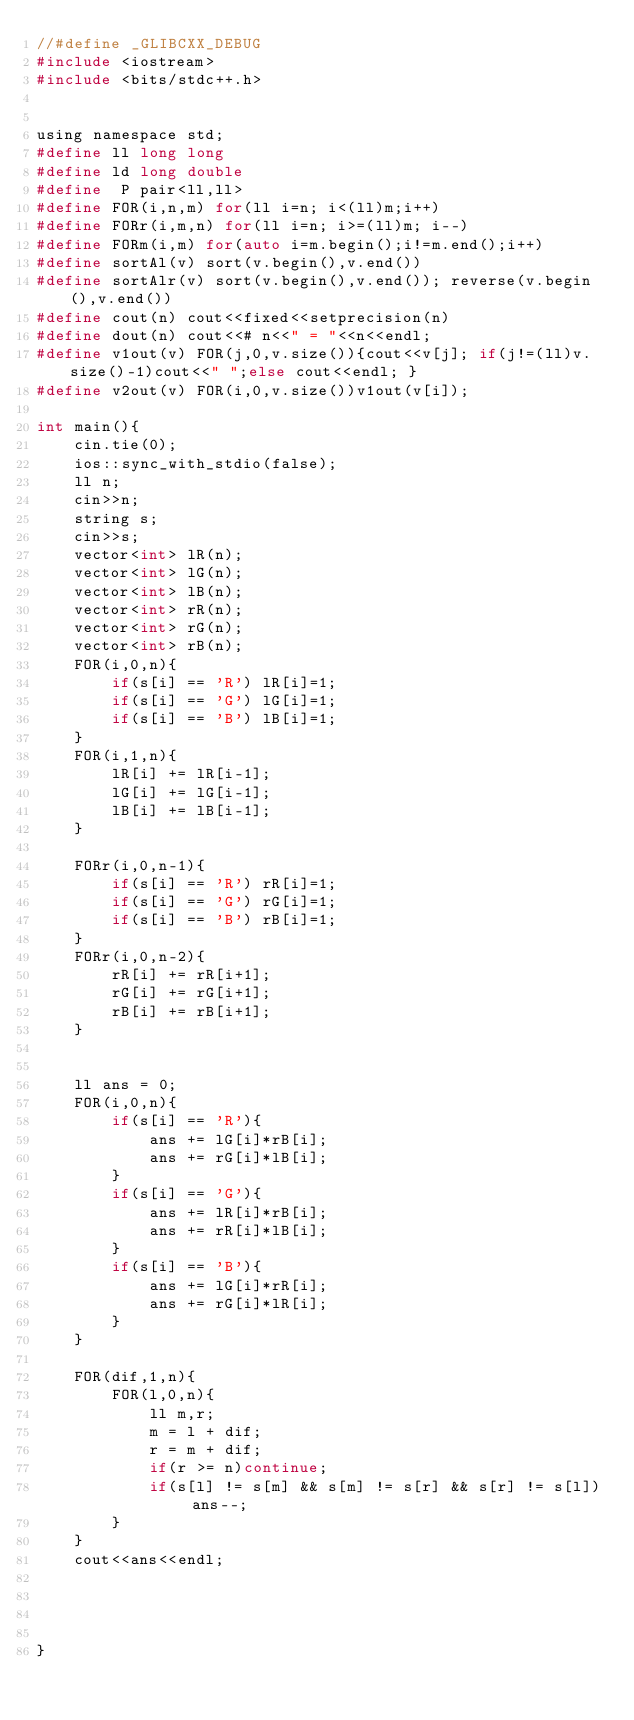Convert code to text. <code><loc_0><loc_0><loc_500><loc_500><_C_>//#define _GLIBCXX_DEBUG
#include <iostream>
#include <bits/stdc++.h>
    
    
using namespace std;
#define ll long long
#define ld long double
#define  P pair<ll,ll>
#define FOR(i,n,m) for(ll i=n; i<(ll)m;i++)
#define FORr(i,m,n) for(ll i=n; i>=(ll)m; i--)
#define FORm(i,m) for(auto i=m.begin();i!=m.end();i++)
#define sortAl(v) sort(v.begin(),v.end())
#define sortAlr(v) sort(v.begin(),v.end()); reverse(v.begin(),v.end())
#define cout(n) cout<<fixed<<setprecision(n)
#define dout(n) cout<<# n<<" = "<<n<<endl;
#define v1out(v) FOR(j,0,v.size()){cout<<v[j]; if(j!=(ll)v.size()-1)cout<<" ";else cout<<endl; }
#define v2out(v) FOR(i,0,v.size())v1out(v[i]);

int main(){
    cin.tie(0);
    ios::sync_with_stdio(false);
    ll n;
    cin>>n;
    string s;
    cin>>s;
    vector<int> lR(n);
    vector<int> lG(n);
    vector<int> lB(n);
    vector<int> rR(n);
    vector<int> rG(n);
    vector<int> rB(n);
    FOR(i,0,n){
        if(s[i] == 'R') lR[i]=1;
        if(s[i] == 'G') lG[i]=1;
        if(s[i] == 'B') lB[i]=1;        
    }
    FOR(i,1,n){
        lR[i] += lR[i-1];
        lG[i] += lG[i-1];
        lB[i] += lB[i-1];        
    }

    FORr(i,0,n-1){
        if(s[i] == 'R') rR[i]=1;
        if(s[i] == 'G') rG[i]=1;
        if(s[i] == 'B') rB[i]=1;        
    }
    FORr(i,0,n-2){
        rR[i] += rR[i+1];
        rG[i] += rG[i+1];
        rB[i] += rB[i+1];        
    }


    ll ans = 0;
    FOR(i,0,n){
        if(s[i] == 'R'){
            ans += lG[i]*rB[i];
            ans += rG[i]*lB[i];            
        }
        if(s[i] == 'G'){
            ans += lR[i]*rB[i];
            ans += rR[i]*lB[i];            
        }
        if(s[i] == 'B'){
            ans += lG[i]*rR[i];
            ans += rG[i]*lR[i];            
        }       
    }   

    FOR(dif,1,n){
        FOR(l,0,n){
            ll m,r;
            m = l + dif;
            r = m + dif;
            if(r >= n)continue;
            if(s[l] != s[m] && s[m] != s[r] && s[r] != s[l]) ans--;
        }
    }
    cout<<ans<<endl;
    

    
    
}</code> 